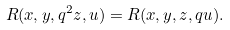Convert formula to latex. <formula><loc_0><loc_0><loc_500><loc_500>R ( x , y , q ^ { 2 } z , u ) = R ( x , y , z , q u ) .</formula> 